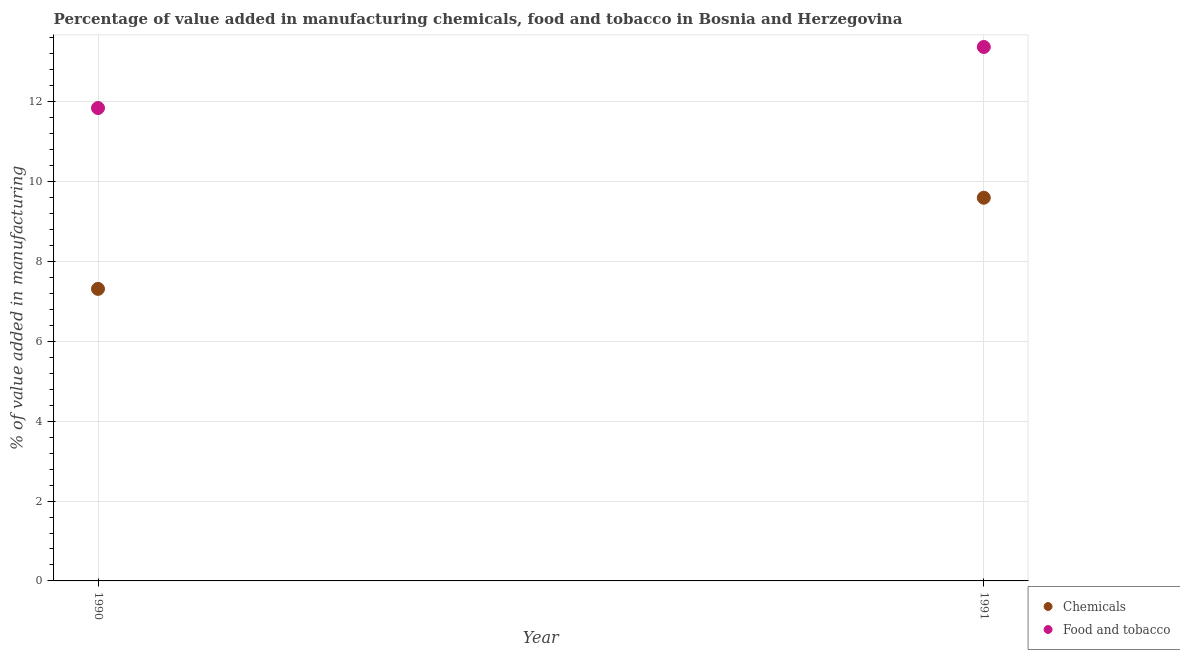How many different coloured dotlines are there?
Your answer should be compact. 2. Is the number of dotlines equal to the number of legend labels?
Offer a terse response. Yes. What is the value added by manufacturing food and tobacco in 1990?
Offer a very short reply. 11.85. Across all years, what is the maximum value added by  manufacturing chemicals?
Make the answer very short. 9.6. Across all years, what is the minimum value added by  manufacturing chemicals?
Offer a terse response. 7.31. What is the total value added by manufacturing food and tobacco in the graph?
Offer a very short reply. 25.22. What is the difference between the value added by  manufacturing chemicals in 1990 and that in 1991?
Your answer should be very brief. -2.28. What is the difference between the value added by manufacturing food and tobacco in 1990 and the value added by  manufacturing chemicals in 1991?
Make the answer very short. 2.25. What is the average value added by manufacturing food and tobacco per year?
Offer a terse response. 12.61. In the year 1991, what is the difference between the value added by  manufacturing chemicals and value added by manufacturing food and tobacco?
Offer a very short reply. -3.78. In how many years, is the value added by  manufacturing chemicals greater than 2.8 %?
Your answer should be compact. 2. What is the ratio of the value added by manufacturing food and tobacco in 1990 to that in 1991?
Offer a very short reply. 0.89. Does the value added by  manufacturing chemicals monotonically increase over the years?
Provide a short and direct response. Yes. Is the value added by  manufacturing chemicals strictly greater than the value added by manufacturing food and tobacco over the years?
Your response must be concise. No. Is the value added by  manufacturing chemicals strictly less than the value added by manufacturing food and tobacco over the years?
Provide a succinct answer. Yes. How many years are there in the graph?
Give a very brief answer. 2. Does the graph contain grids?
Keep it short and to the point. Yes. How many legend labels are there?
Provide a short and direct response. 2. How are the legend labels stacked?
Your answer should be compact. Vertical. What is the title of the graph?
Keep it short and to the point. Percentage of value added in manufacturing chemicals, food and tobacco in Bosnia and Herzegovina. Does "Formally registered" appear as one of the legend labels in the graph?
Provide a short and direct response. No. What is the label or title of the X-axis?
Ensure brevity in your answer.  Year. What is the label or title of the Y-axis?
Ensure brevity in your answer.  % of value added in manufacturing. What is the % of value added in manufacturing of Chemicals in 1990?
Ensure brevity in your answer.  7.31. What is the % of value added in manufacturing of Food and tobacco in 1990?
Offer a very short reply. 11.85. What is the % of value added in manufacturing in Chemicals in 1991?
Offer a terse response. 9.6. What is the % of value added in manufacturing of Food and tobacco in 1991?
Provide a succinct answer. 13.37. Across all years, what is the maximum % of value added in manufacturing in Chemicals?
Ensure brevity in your answer.  9.6. Across all years, what is the maximum % of value added in manufacturing in Food and tobacco?
Your answer should be very brief. 13.37. Across all years, what is the minimum % of value added in manufacturing of Chemicals?
Ensure brevity in your answer.  7.31. Across all years, what is the minimum % of value added in manufacturing of Food and tobacco?
Offer a terse response. 11.85. What is the total % of value added in manufacturing in Chemicals in the graph?
Offer a terse response. 16.91. What is the total % of value added in manufacturing in Food and tobacco in the graph?
Your answer should be very brief. 25.22. What is the difference between the % of value added in manufacturing in Chemicals in 1990 and that in 1991?
Your answer should be compact. -2.28. What is the difference between the % of value added in manufacturing of Food and tobacco in 1990 and that in 1991?
Your response must be concise. -1.53. What is the difference between the % of value added in manufacturing in Chemicals in 1990 and the % of value added in manufacturing in Food and tobacco in 1991?
Your answer should be compact. -6.06. What is the average % of value added in manufacturing in Chemicals per year?
Your response must be concise. 8.46. What is the average % of value added in manufacturing in Food and tobacco per year?
Provide a short and direct response. 12.61. In the year 1990, what is the difference between the % of value added in manufacturing of Chemicals and % of value added in manufacturing of Food and tobacco?
Your answer should be compact. -4.53. In the year 1991, what is the difference between the % of value added in manufacturing of Chemicals and % of value added in manufacturing of Food and tobacco?
Give a very brief answer. -3.78. What is the ratio of the % of value added in manufacturing in Chemicals in 1990 to that in 1991?
Offer a terse response. 0.76. What is the ratio of the % of value added in manufacturing of Food and tobacco in 1990 to that in 1991?
Your answer should be compact. 0.89. What is the difference between the highest and the second highest % of value added in manufacturing of Chemicals?
Provide a short and direct response. 2.28. What is the difference between the highest and the second highest % of value added in manufacturing in Food and tobacco?
Your response must be concise. 1.53. What is the difference between the highest and the lowest % of value added in manufacturing in Chemicals?
Make the answer very short. 2.28. What is the difference between the highest and the lowest % of value added in manufacturing of Food and tobacco?
Offer a terse response. 1.53. 